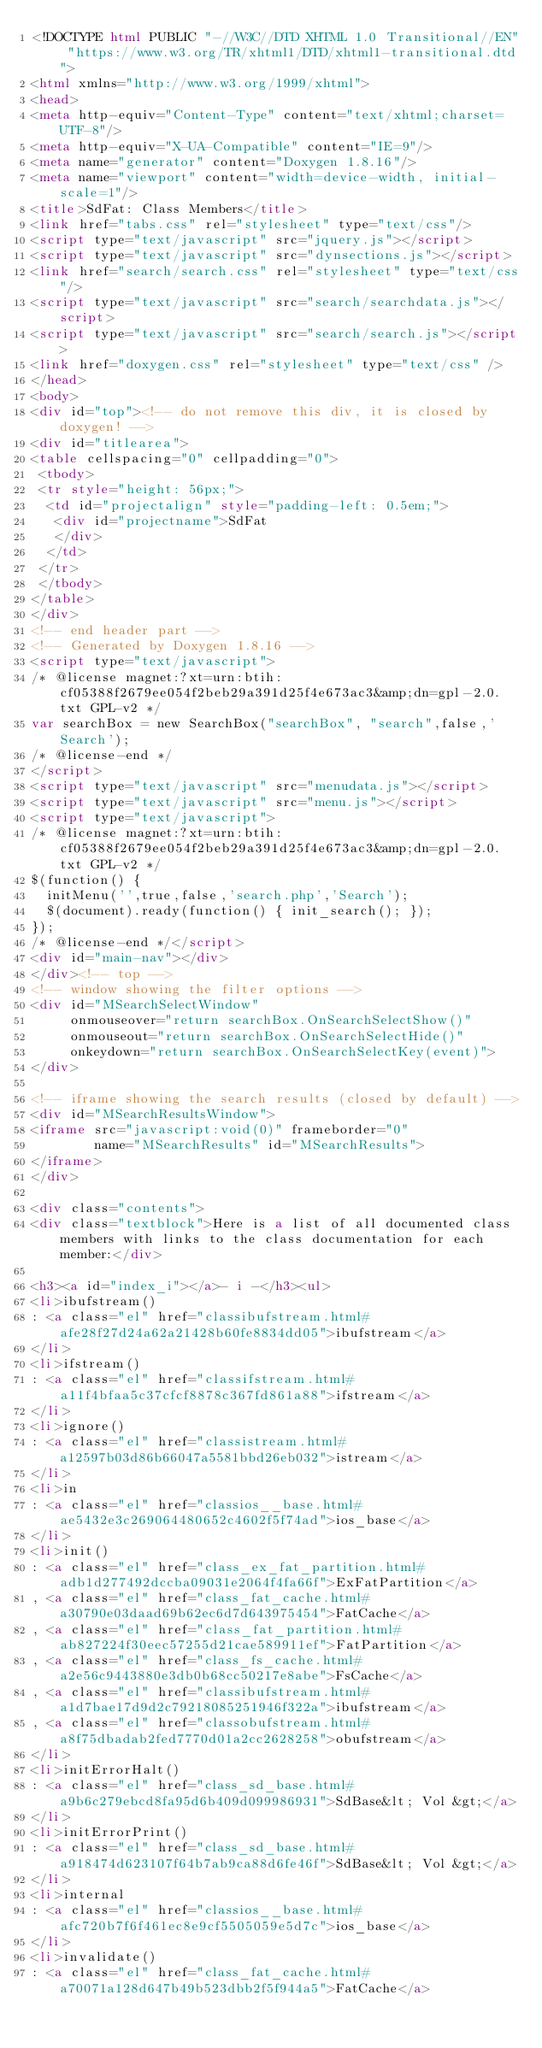<code> <loc_0><loc_0><loc_500><loc_500><_HTML_><!DOCTYPE html PUBLIC "-//W3C//DTD XHTML 1.0 Transitional//EN" "https://www.w3.org/TR/xhtml1/DTD/xhtml1-transitional.dtd">
<html xmlns="http://www.w3.org/1999/xhtml">
<head>
<meta http-equiv="Content-Type" content="text/xhtml;charset=UTF-8"/>
<meta http-equiv="X-UA-Compatible" content="IE=9"/>
<meta name="generator" content="Doxygen 1.8.16"/>
<meta name="viewport" content="width=device-width, initial-scale=1"/>
<title>SdFat: Class Members</title>
<link href="tabs.css" rel="stylesheet" type="text/css"/>
<script type="text/javascript" src="jquery.js"></script>
<script type="text/javascript" src="dynsections.js"></script>
<link href="search/search.css" rel="stylesheet" type="text/css"/>
<script type="text/javascript" src="search/searchdata.js"></script>
<script type="text/javascript" src="search/search.js"></script>
<link href="doxygen.css" rel="stylesheet" type="text/css" />
</head>
<body>
<div id="top"><!-- do not remove this div, it is closed by doxygen! -->
<div id="titlearea">
<table cellspacing="0" cellpadding="0">
 <tbody>
 <tr style="height: 56px;">
  <td id="projectalign" style="padding-left: 0.5em;">
   <div id="projectname">SdFat
   </div>
  </td>
 </tr>
 </tbody>
</table>
</div>
<!-- end header part -->
<!-- Generated by Doxygen 1.8.16 -->
<script type="text/javascript">
/* @license magnet:?xt=urn:btih:cf05388f2679ee054f2beb29a391d25f4e673ac3&amp;dn=gpl-2.0.txt GPL-v2 */
var searchBox = new SearchBox("searchBox", "search",false,'Search');
/* @license-end */
</script>
<script type="text/javascript" src="menudata.js"></script>
<script type="text/javascript" src="menu.js"></script>
<script type="text/javascript">
/* @license magnet:?xt=urn:btih:cf05388f2679ee054f2beb29a391d25f4e673ac3&amp;dn=gpl-2.0.txt GPL-v2 */
$(function() {
  initMenu('',true,false,'search.php','Search');
  $(document).ready(function() { init_search(); });
});
/* @license-end */</script>
<div id="main-nav"></div>
</div><!-- top -->
<!-- window showing the filter options -->
<div id="MSearchSelectWindow"
     onmouseover="return searchBox.OnSearchSelectShow()"
     onmouseout="return searchBox.OnSearchSelectHide()"
     onkeydown="return searchBox.OnSearchSelectKey(event)">
</div>

<!-- iframe showing the search results (closed by default) -->
<div id="MSearchResultsWindow">
<iframe src="javascript:void(0)" frameborder="0" 
        name="MSearchResults" id="MSearchResults">
</iframe>
</div>

<div class="contents">
<div class="textblock">Here is a list of all documented class members with links to the class documentation for each member:</div>

<h3><a id="index_i"></a>- i -</h3><ul>
<li>ibufstream()
: <a class="el" href="classibufstream.html#afe28f27d24a62a21428b60fe8834dd05">ibufstream</a>
</li>
<li>ifstream()
: <a class="el" href="classifstream.html#a11f4bfaa5c37cfcf8878c367fd861a88">ifstream</a>
</li>
<li>ignore()
: <a class="el" href="classistream.html#a12597b03d86b66047a5581bbd26eb032">istream</a>
</li>
<li>in
: <a class="el" href="classios__base.html#ae5432e3c269064480652c4602f5f74ad">ios_base</a>
</li>
<li>init()
: <a class="el" href="class_ex_fat_partition.html#adb1d277492dccba09031e2064f4fa66f">ExFatPartition</a>
, <a class="el" href="class_fat_cache.html#a30790e03daad69b62ec6d7d643975454">FatCache</a>
, <a class="el" href="class_fat_partition.html#ab827224f30eec57255d21cae589911ef">FatPartition</a>
, <a class="el" href="class_fs_cache.html#a2e56c9443880e3db0b68cc50217e8abe">FsCache</a>
, <a class="el" href="classibufstream.html#a1d7bae17d9d2c79218085251946f322a">ibufstream</a>
, <a class="el" href="classobufstream.html#a8f75dbadab2fed7770d01a2cc2628258">obufstream</a>
</li>
<li>initErrorHalt()
: <a class="el" href="class_sd_base.html#a9b6c279ebcd8fa95d6b409d099986931">SdBase&lt; Vol &gt;</a>
</li>
<li>initErrorPrint()
: <a class="el" href="class_sd_base.html#a918474d623107f64b7ab9ca88d6fe46f">SdBase&lt; Vol &gt;</a>
</li>
<li>internal
: <a class="el" href="classios__base.html#afc720b7f6f461ec8e9cf5505059e5d7c">ios_base</a>
</li>
<li>invalidate()
: <a class="el" href="class_fat_cache.html#a70071a128d647b49b523dbb2f5f944a5">FatCache</a></code> 